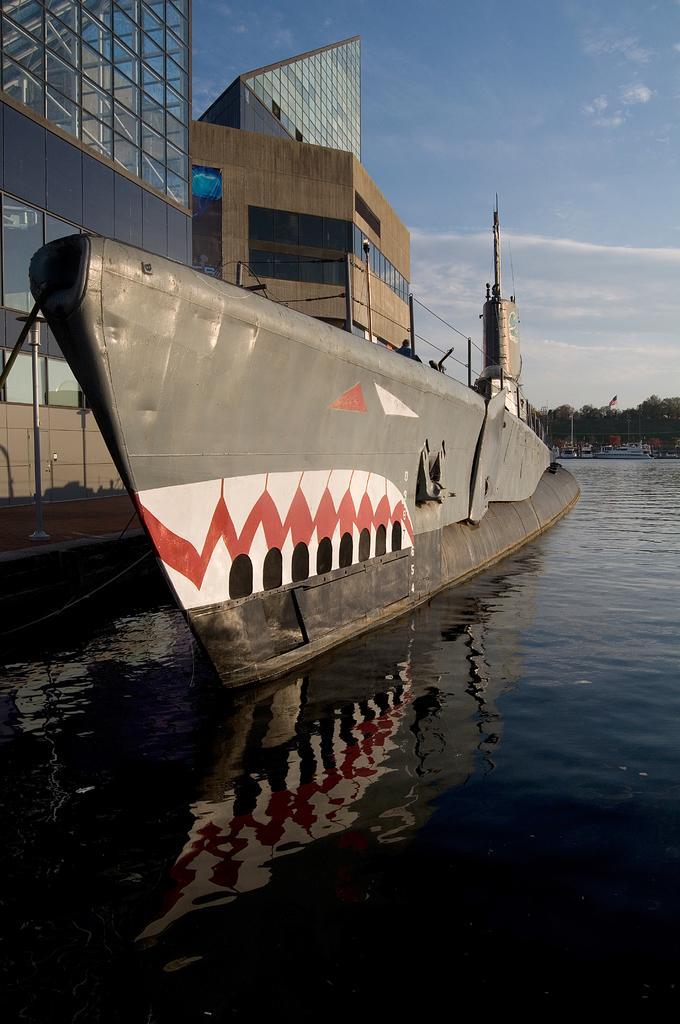Please provide a concise description of this image. This image consists of a ship. At the bottom, there is water. On the left, we can see the buildings along with windows. At the top, there are clouds in the sky. In the background, there are trees. 